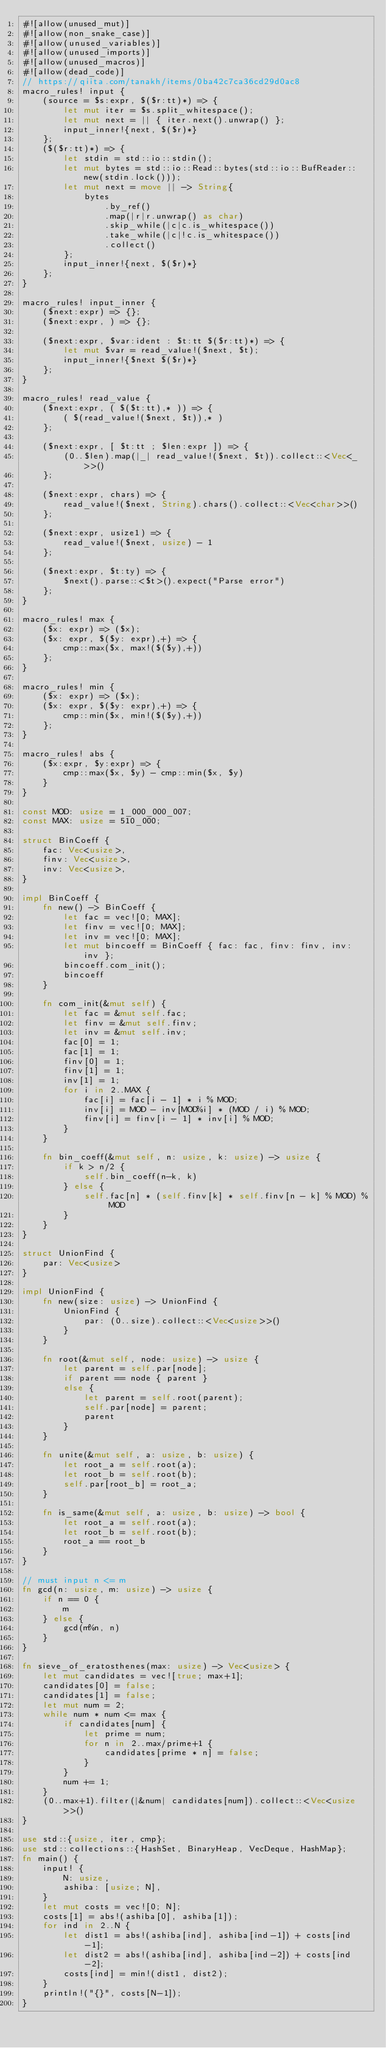Convert code to text. <code><loc_0><loc_0><loc_500><loc_500><_Rust_>#![allow(unused_mut)]
#![allow(non_snake_case)]
#![allow(unused_variables)]
#![allow(unused_imports)]
#![allow(unused_macros)]
#![allow(dead_code)]
// https://qiita.com/tanakh/items/0ba42c7ca36cd29d0ac8
macro_rules! input {
    (source = $s:expr, $($r:tt)*) => {
        let mut iter = $s.split_whitespace();
        let mut next = || { iter.next().unwrap() };
        input_inner!{next, $($r)*}
    };
    ($($r:tt)*) => {
        let stdin = std::io::stdin();
        let mut bytes = std::io::Read::bytes(std::io::BufReader::new(stdin.lock()));
        let mut next = move || -> String{
            bytes
                .by_ref()
                .map(|r|r.unwrap() as char)
                .skip_while(|c|c.is_whitespace())
                .take_while(|c|!c.is_whitespace())
                .collect()
        };
        input_inner!{next, $($r)*}
    };
}

macro_rules! input_inner {
    ($next:expr) => {};
    ($next:expr, ) => {};

    ($next:expr, $var:ident : $t:tt $($r:tt)*) => {
        let mut $var = read_value!($next, $t);
        input_inner!{$next $($r)*}
    };
}

macro_rules! read_value {
    ($next:expr, ( $($t:tt),* )) => {
        ( $(read_value!($next, $t)),* )
    };

    ($next:expr, [ $t:tt ; $len:expr ]) => {
        (0..$len).map(|_| read_value!($next, $t)).collect::<Vec<_>>()
    };

    ($next:expr, chars) => {
        read_value!($next, String).chars().collect::<Vec<char>>()
    };

    ($next:expr, usize1) => {
        read_value!($next, usize) - 1
    };

    ($next:expr, $t:ty) => {
        $next().parse::<$t>().expect("Parse error")
    };
}

macro_rules! max {
    ($x: expr) => ($x);
    ($x: expr, $($y: expr),+) => {
        cmp::max($x, max!($($y),+))
    };
}

macro_rules! min {
    ($x: expr) => ($x);
    ($x: expr, $($y: expr),+) => {
        cmp::min($x, min!($($y),+))
    };
}

macro_rules! abs {
    ($x:expr, $y:expr) => {
        cmp::max($x, $y) - cmp::min($x, $y)
    }
}

const MOD: usize = 1_000_000_007;
const MAX: usize = 510_000;

struct BinCoeff {
    fac: Vec<usize>,
    finv: Vec<usize>,
    inv: Vec<usize>,
}

impl BinCoeff {
    fn new() -> BinCoeff {
        let fac = vec![0; MAX];
        let finv = vec![0; MAX];
        let inv = vec![0; MAX];
        let mut bincoeff = BinCoeff { fac: fac, finv: finv, inv: inv };
        bincoeff.com_init();
        bincoeff
    }

    fn com_init(&mut self) {
        let fac = &mut self.fac;
        let finv = &mut self.finv;
        let inv = &mut self.inv;
        fac[0] = 1;
        fac[1] = 1;
        finv[0] = 1;
        finv[1] = 1;
        inv[1] = 1;
        for i in 2..MAX {
            fac[i] = fac[i - 1] * i % MOD;
            inv[i] = MOD - inv[MOD%i] * (MOD / i) % MOD;
            finv[i] = finv[i - 1] * inv[i] % MOD;
        }
    }

    fn bin_coeff(&mut self, n: usize, k: usize) -> usize {
        if k > n/2 {
            self.bin_coeff(n-k, k)
        } else {
            self.fac[n] * (self.finv[k] * self.finv[n - k] % MOD) % MOD
        }
    }
}

struct UnionFind {
    par: Vec<usize>
}

impl UnionFind {
    fn new(size: usize) -> UnionFind {
        UnionFind {
            par: (0..size).collect::<Vec<usize>>()
        }
    }

    fn root(&mut self, node: usize) -> usize {
        let parent = self.par[node];
        if parent == node { parent }
        else {
            let parent = self.root(parent);
            self.par[node] = parent;
            parent
        }
    }

    fn unite(&mut self, a: usize, b: usize) {
        let root_a = self.root(a);
        let root_b = self.root(b);
        self.par[root_b] = root_a;
    }

    fn is_same(&mut self, a: usize, b: usize) -> bool {
        let root_a = self.root(a);
        let root_b = self.root(b);
        root_a == root_b
    }
}

// must input n <= m
fn gcd(n: usize, m: usize) -> usize {
    if n == 0 {
        m
    } else {
        gcd(m%n, n)
    }
}

fn sieve_of_eratosthenes(max: usize) -> Vec<usize> {
    let mut candidates = vec![true; max+1];
    candidates[0] = false;
    candidates[1] = false;
    let mut num = 2;
    while num * num <= max {
        if candidates[num] {
            let prime = num;
            for n in 2..max/prime+1 {
                candidates[prime * n] = false;
            }
        }
        num += 1;
    }
    (0..max+1).filter(|&num| candidates[num]).collect::<Vec<usize>>()
}

use std::{usize, iter, cmp};
use std::collections::{HashSet, BinaryHeap, VecDeque, HashMap};
fn main() {
    input! {
        N: usize,
        ashiba: [usize; N],
    }
    let mut costs = vec![0; N];
    costs[1] = abs!(ashiba[0], ashiba[1]);
    for ind in 2..N {
        let dist1 = abs!(ashiba[ind], ashiba[ind-1]) + costs[ind-1];
        let dist2 = abs!(ashiba[ind], ashiba[ind-2]) + costs[ind-2];
        costs[ind] = min!(dist1, dist2);
    }
    println!("{}", costs[N-1]);
}

</code> 